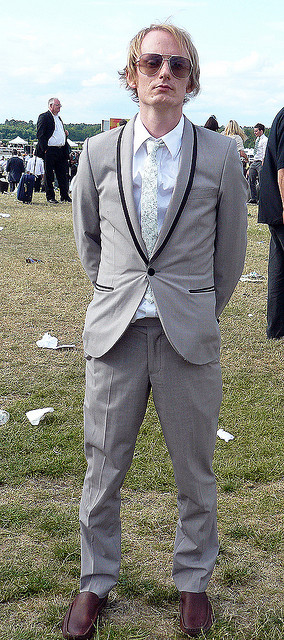<image>What is these men's profession? I don't know the profession of these men. It could be anything from a driver, teacher, businessman, tailor, golfer, manager, student or an actor. What is these men's profession? It is not clear what these men's profession is. Some possible professions could be driver, teacher, businessman, tailor, golfer, manager, student, actor, or business. 